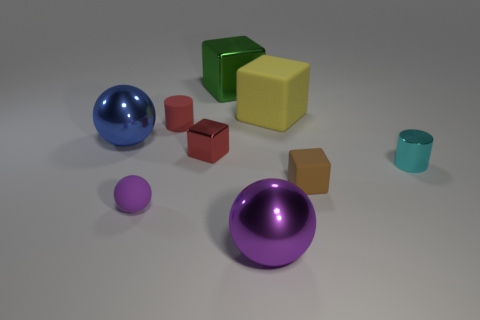Subtract all yellow cubes. How many cubes are left? 3 Subtract all red cubes. How many cubes are left? 3 Add 1 tiny balls. How many objects exist? 10 Subtract all blue cubes. Subtract all red cylinders. How many cubes are left? 4 Subtract all spheres. How many objects are left? 6 Subtract all blue metallic spheres. Subtract all green metal things. How many objects are left? 7 Add 1 large matte cubes. How many large matte cubes are left? 2 Add 1 big spheres. How many big spheres exist? 3 Subtract 1 cyan cylinders. How many objects are left? 8 